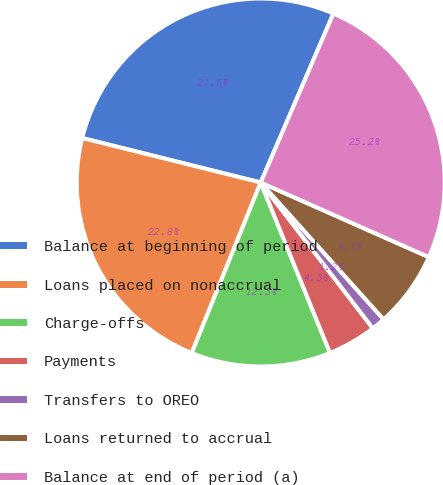Convert chart. <chart><loc_0><loc_0><loc_500><loc_500><pie_chart><fcel>Balance at beginning of period<fcel>Loans placed on nonaccrual<fcel>Charge-offs<fcel>Payments<fcel>Transfers to OREO<fcel>Loans returned to accrual<fcel>Balance at end of period (a)<nl><fcel>27.58%<fcel>22.77%<fcel>12.26%<fcel>4.29%<fcel>1.21%<fcel>6.71%<fcel>25.18%<nl></chart> 